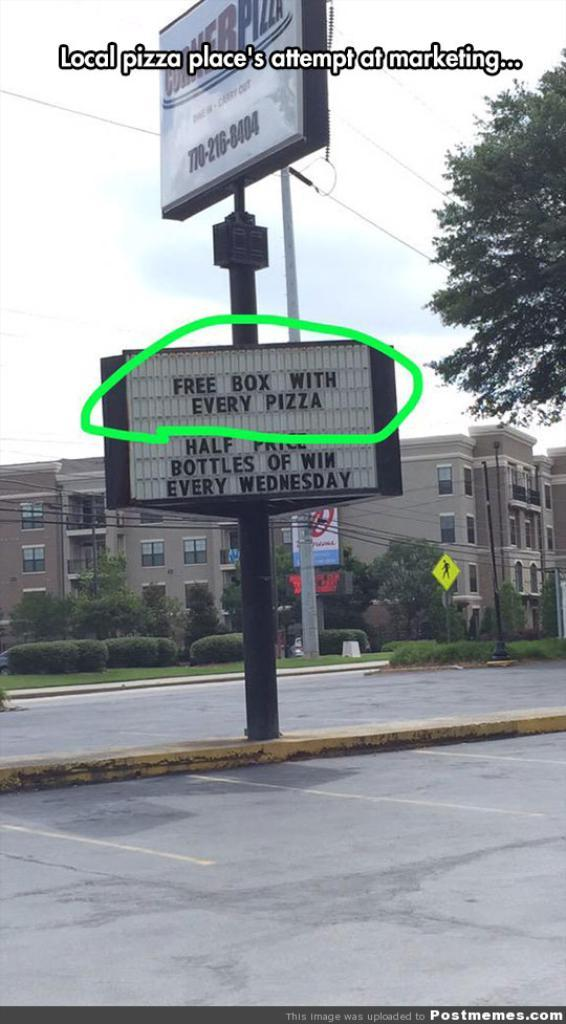<image>
Create a compact narrative representing the image presented. a sign reads Free Box with Every Pizza 